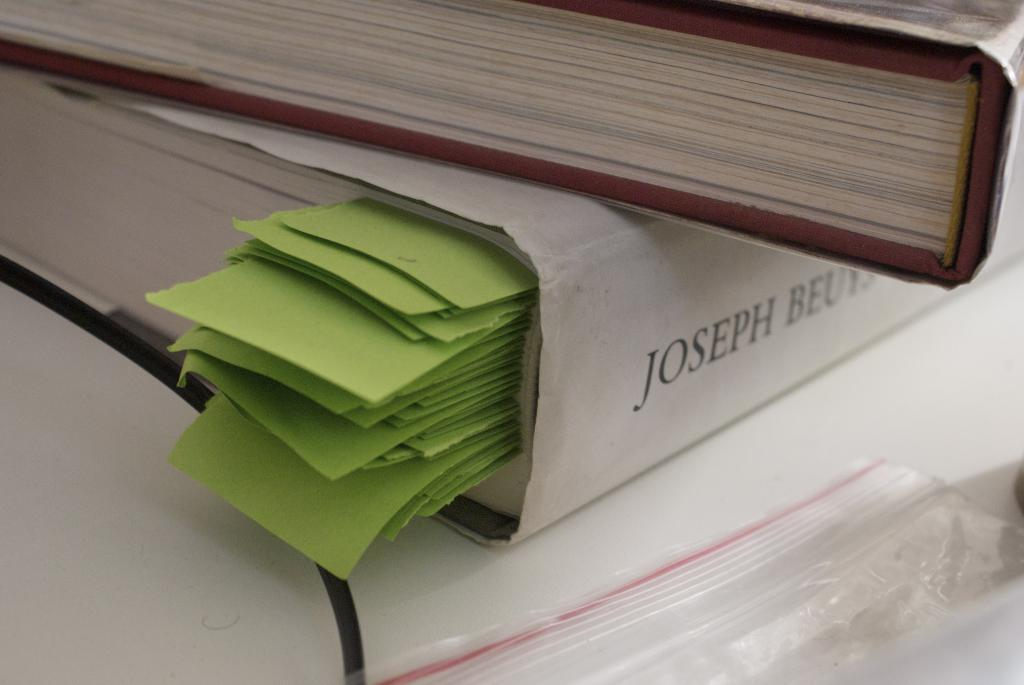<image>
Create a compact narrative representing the image presented. A book by Joseph has many pages marked with green tabs. 